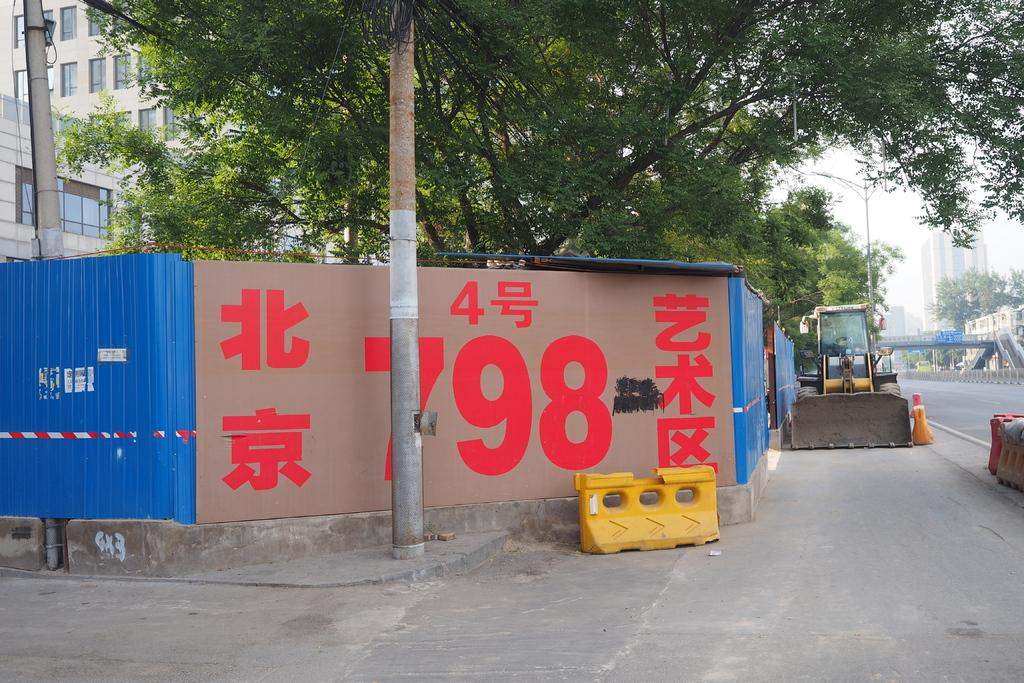<image>
Give a short and clear explanation of the subsequent image. A brown wall with red chinese characters on it. 